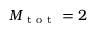<formula> <loc_0><loc_0><loc_500><loc_500>M _ { t o t } = 2</formula> 